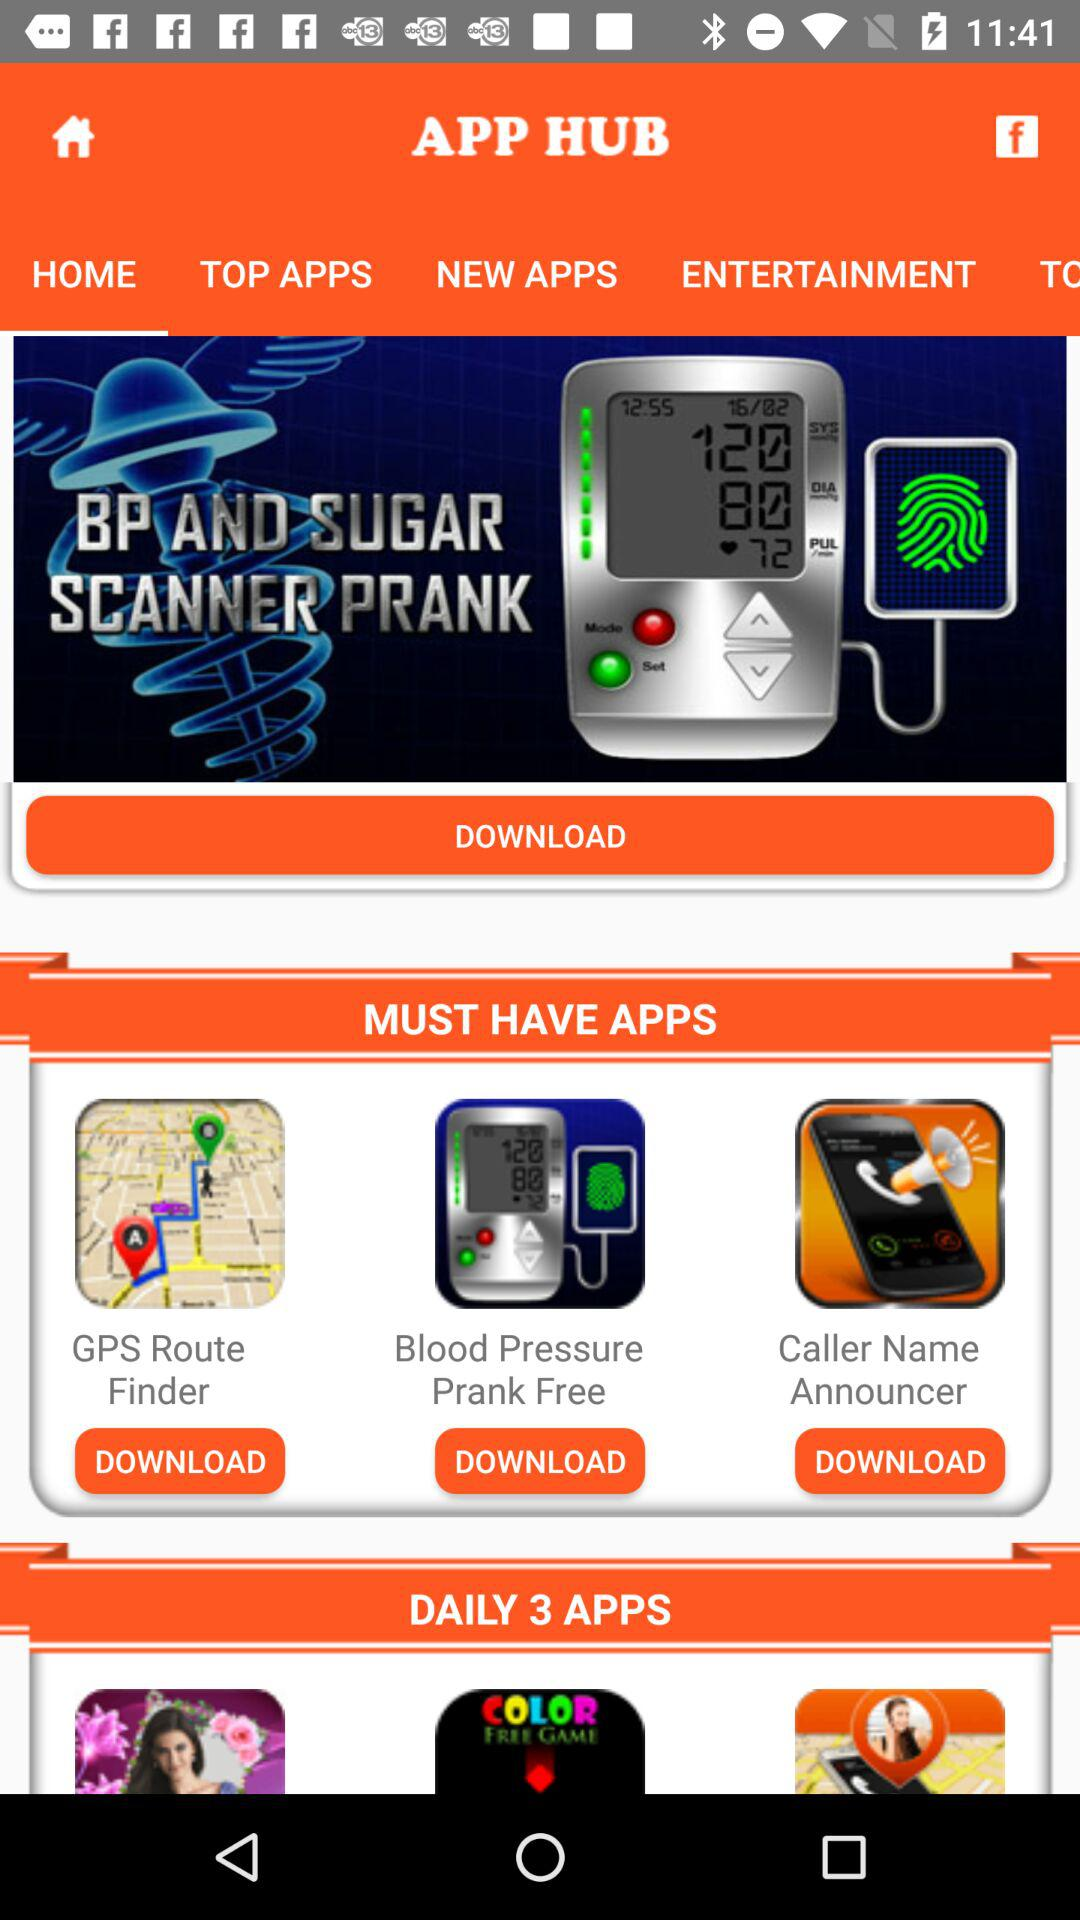What is the application name? The application name is "APP HUB". 